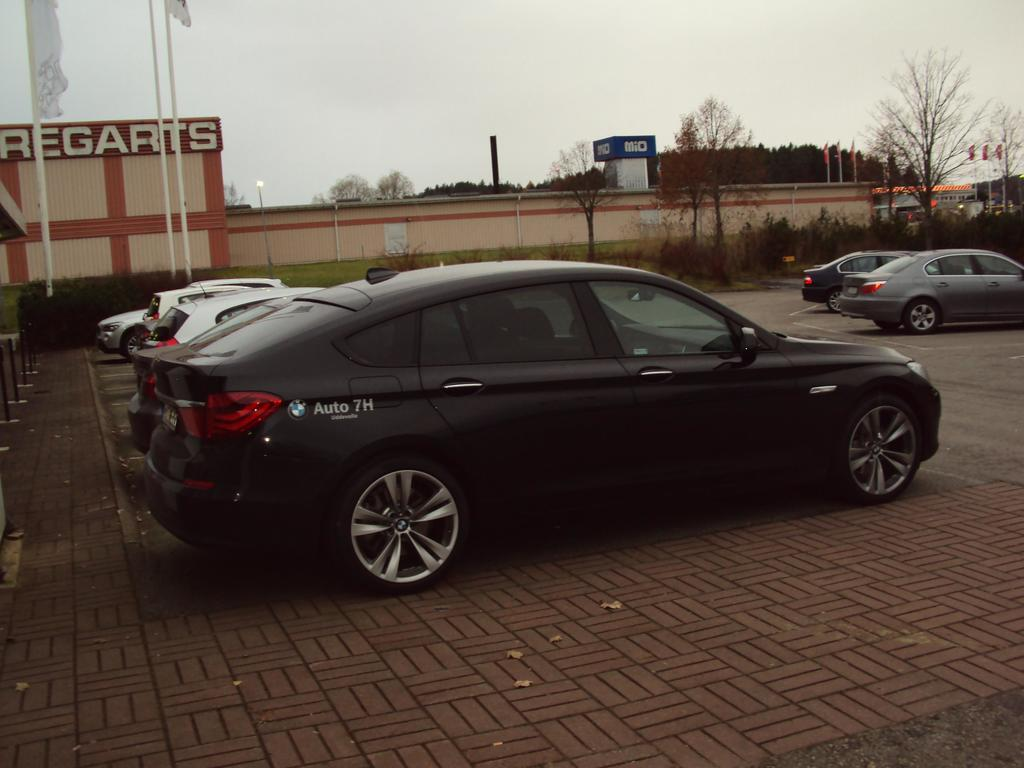What is located in the middle of the image? There are cars in the middle of the image. What can be seen in the background of the image? There is a wall and trees in the background of the image. What is visible at the top of the image? The sky is visible at the top of the image. How much growth has the loaf experienced in the image? There is no loaf present in the image, so it is not possible to determine its growth. 